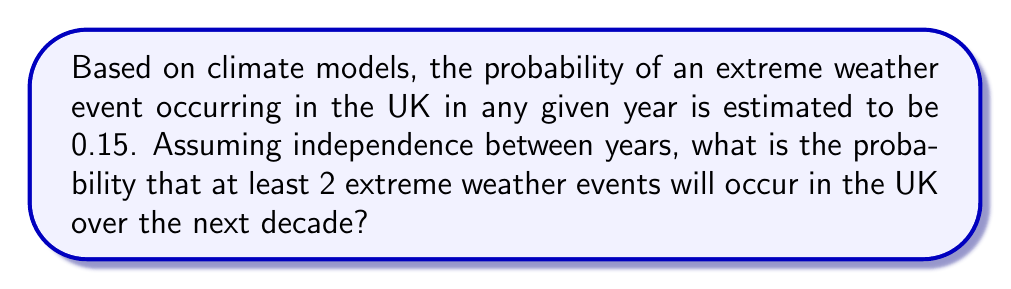Can you answer this question? Let's approach this step-by-step:

1) First, we need to identify the probability distribution. This scenario follows a Binomial distribution, where:
   n = 10 (number of years)
   p = 0.15 (probability of an extreme weather event in a year)

2) We want the probability of at least 2 events, which is equivalent to 1 minus the probability of 0 or 1 event.

3) The probability mass function for a Binomial distribution is:

   $$P(X = k) = \binom{n}{k} p^k (1-p)^{n-k}$$

4) Let's calculate P(X = 0) and P(X = 1):

   P(X = 0) = $\binom{10}{0} (0.15)^0 (0.85)^{10} = 0.85^{10} \approx 0.1969$

   P(X = 1) = $\binom{10}{1} (0.15)^1 (0.85)^9 = 10 \cdot 0.15 \cdot 0.85^9 \approx 0.3474$

5) The probability of at least 2 events is:

   P(X ≥ 2) = 1 - P(X < 2) = 1 - [P(X = 0) + P(X = 1)]

6) Substituting the values:

   P(X ≥ 2) = 1 - (0.1969 + 0.3474) = 1 - 0.5443 = 0.4557

Therefore, the probability of at least 2 extreme weather events occurring in the UK over the next decade is approximately 0.4557 or 45.57%.
Answer: 0.4557 